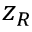<formula> <loc_0><loc_0><loc_500><loc_500>z _ { R }</formula> 